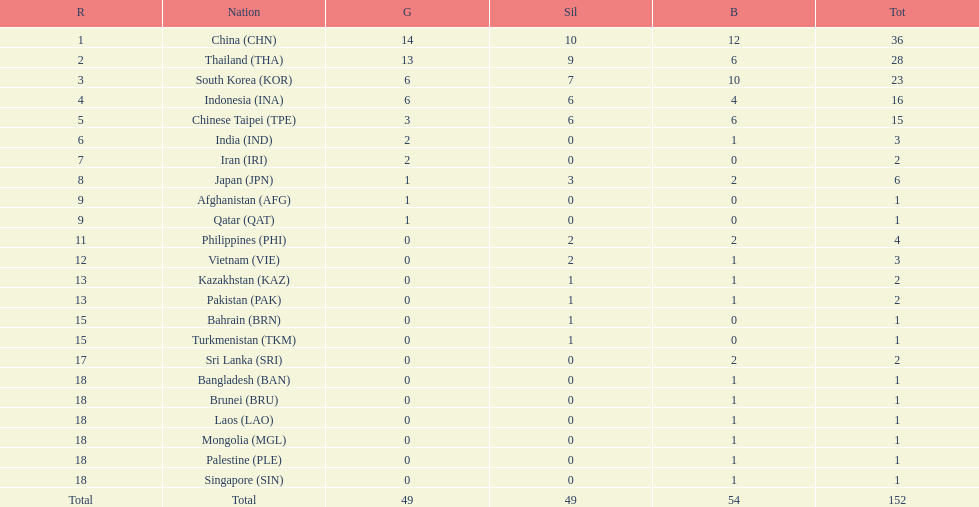Did the philippines or kazakhstan have a higher number of total medals? Philippines. 